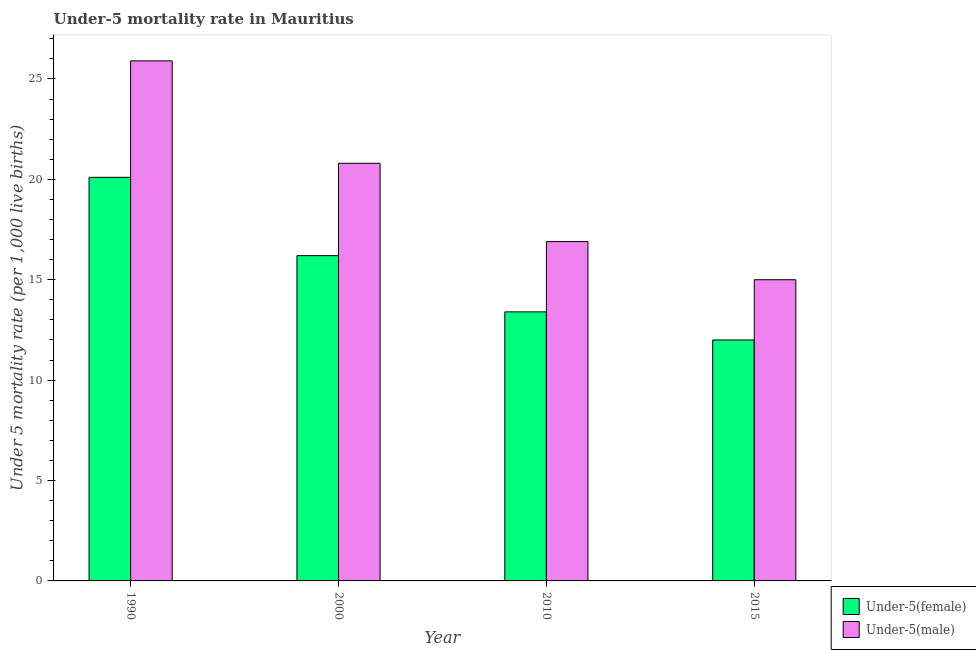How many groups of bars are there?
Keep it short and to the point. 4. Are the number of bars per tick equal to the number of legend labels?
Your response must be concise. Yes. Are the number of bars on each tick of the X-axis equal?
Keep it short and to the point. Yes. How many bars are there on the 1st tick from the left?
Offer a terse response. 2. How many bars are there on the 3rd tick from the right?
Provide a succinct answer. 2. What is the under-5 male mortality rate in 2000?
Your answer should be very brief. 20.8. Across all years, what is the maximum under-5 male mortality rate?
Ensure brevity in your answer.  25.9. Across all years, what is the minimum under-5 male mortality rate?
Provide a short and direct response. 15. In which year was the under-5 male mortality rate minimum?
Give a very brief answer. 2015. What is the total under-5 female mortality rate in the graph?
Make the answer very short. 61.7. What is the difference between the under-5 male mortality rate in 1990 and that in 2010?
Your response must be concise. 9. What is the difference between the under-5 male mortality rate in 2000 and the under-5 female mortality rate in 2010?
Your answer should be compact. 3.9. What is the average under-5 male mortality rate per year?
Give a very brief answer. 19.65. In the year 2000, what is the difference between the under-5 female mortality rate and under-5 male mortality rate?
Your response must be concise. 0. What is the ratio of the under-5 female mortality rate in 2010 to that in 2015?
Your answer should be very brief. 1.12. What is the difference between the highest and the second highest under-5 female mortality rate?
Offer a terse response. 3.9. What is the difference between the highest and the lowest under-5 female mortality rate?
Offer a very short reply. 8.1. In how many years, is the under-5 female mortality rate greater than the average under-5 female mortality rate taken over all years?
Provide a succinct answer. 2. Is the sum of the under-5 male mortality rate in 2000 and 2015 greater than the maximum under-5 female mortality rate across all years?
Offer a terse response. Yes. What does the 2nd bar from the left in 1990 represents?
Your answer should be compact. Under-5(male). What does the 2nd bar from the right in 1990 represents?
Your response must be concise. Under-5(female). How many bars are there?
Provide a short and direct response. 8. Are the values on the major ticks of Y-axis written in scientific E-notation?
Give a very brief answer. No. Does the graph contain any zero values?
Offer a very short reply. No. Does the graph contain grids?
Your answer should be very brief. No. Where does the legend appear in the graph?
Give a very brief answer. Bottom right. How are the legend labels stacked?
Your answer should be very brief. Vertical. What is the title of the graph?
Offer a very short reply. Under-5 mortality rate in Mauritius. What is the label or title of the X-axis?
Provide a succinct answer. Year. What is the label or title of the Y-axis?
Provide a succinct answer. Under 5 mortality rate (per 1,0 live births). What is the Under 5 mortality rate (per 1,000 live births) in Under-5(female) in 1990?
Give a very brief answer. 20.1. What is the Under 5 mortality rate (per 1,000 live births) in Under-5(male) in 1990?
Offer a very short reply. 25.9. What is the Under 5 mortality rate (per 1,000 live births) in Under-5(female) in 2000?
Your answer should be compact. 16.2. What is the Under 5 mortality rate (per 1,000 live births) of Under-5(male) in 2000?
Keep it short and to the point. 20.8. What is the Under 5 mortality rate (per 1,000 live births) of Under-5(male) in 2010?
Offer a very short reply. 16.9. What is the Under 5 mortality rate (per 1,000 live births) of Under-5(male) in 2015?
Your answer should be compact. 15. Across all years, what is the maximum Under 5 mortality rate (per 1,000 live births) in Under-5(female)?
Provide a succinct answer. 20.1. Across all years, what is the maximum Under 5 mortality rate (per 1,000 live births) of Under-5(male)?
Give a very brief answer. 25.9. Across all years, what is the minimum Under 5 mortality rate (per 1,000 live births) in Under-5(female)?
Keep it short and to the point. 12. Across all years, what is the minimum Under 5 mortality rate (per 1,000 live births) of Under-5(male)?
Provide a short and direct response. 15. What is the total Under 5 mortality rate (per 1,000 live births) of Under-5(female) in the graph?
Your response must be concise. 61.7. What is the total Under 5 mortality rate (per 1,000 live births) of Under-5(male) in the graph?
Provide a short and direct response. 78.6. What is the difference between the Under 5 mortality rate (per 1,000 live births) of Under-5(male) in 1990 and that in 2010?
Give a very brief answer. 9. What is the difference between the Under 5 mortality rate (per 1,000 live births) in Under-5(female) in 1990 and that in 2015?
Your answer should be very brief. 8.1. What is the difference between the Under 5 mortality rate (per 1,000 live births) of Under-5(male) in 1990 and that in 2015?
Offer a very short reply. 10.9. What is the difference between the Under 5 mortality rate (per 1,000 live births) in Under-5(male) in 2000 and that in 2010?
Offer a terse response. 3.9. What is the difference between the Under 5 mortality rate (per 1,000 live births) in Under-5(male) in 2000 and that in 2015?
Keep it short and to the point. 5.8. What is the difference between the Under 5 mortality rate (per 1,000 live births) in Under-5(male) in 2010 and that in 2015?
Give a very brief answer. 1.9. What is the difference between the Under 5 mortality rate (per 1,000 live births) of Under-5(female) in 1990 and the Under 5 mortality rate (per 1,000 live births) of Under-5(male) in 2000?
Provide a short and direct response. -0.7. What is the difference between the Under 5 mortality rate (per 1,000 live births) of Under-5(female) in 1990 and the Under 5 mortality rate (per 1,000 live births) of Under-5(male) in 2010?
Your response must be concise. 3.2. What is the difference between the Under 5 mortality rate (per 1,000 live births) in Under-5(female) in 1990 and the Under 5 mortality rate (per 1,000 live births) in Under-5(male) in 2015?
Ensure brevity in your answer.  5.1. What is the difference between the Under 5 mortality rate (per 1,000 live births) in Under-5(female) in 2010 and the Under 5 mortality rate (per 1,000 live births) in Under-5(male) in 2015?
Keep it short and to the point. -1.6. What is the average Under 5 mortality rate (per 1,000 live births) of Under-5(female) per year?
Make the answer very short. 15.43. What is the average Under 5 mortality rate (per 1,000 live births) of Under-5(male) per year?
Keep it short and to the point. 19.65. In the year 2000, what is the difference between the Under 5 mortality rate (per 1,000 live births) of Under-5(female) and Under 5 mortality rate (per 1,000 live births) of Under-5(male)?
Make the answer very short. -4.6. In the year 2015, what is the difference between the Under 5 mortality rate (per 1,000 live births) in Under-5(female) and Under 5 mortality rate (per 1,000 live births) in Under-5(male)?
Your answer should be compact. -3. What is the ratio of the Under 5 mortality rate (per 1,000 live births) in Under-5(female) in 1990 to that in 2000?
Your answer should be very brief. 1.24. What is the ratio of the Under 5 mortality rate (per 1,000 live births) of Under-5(male) in 1990 to that in 2000?
Your response must be concise. 1.25. What is the ratio of the Under 5 mortality rate (per 1,000 live births) of Under-5(male) in 1990 to that in 2010?
Offer a very short reply. 1.53. What is the ratio of the Under 5 mortality rate (per 1,000 live births) in Under-5(female) in 1990 to that in 2015?
Keep it short and to the point. 1.68. What is the ratio of the Under 5 mortality rate (per 1,000 live births) of Under-5(male) in 1990 to that in 2015?
Your answer should be very brief. 1.73. What is the ratio of the Under 5 mortality rate (per 1,000 live births) in Under-5(female) in 2000 to that in 2010?
Give a very brief answer. 1.21. What is the ratio of the Under 5 mortality rate (per 1,000 live births) in Under-5(male) in 2000 to that in 2010?
Offer a very short reply. 1.23. What is the ratio of the Under 5 mortality rate (per 1,000 live births) of Under-5(female) in 2000 to that in 2015?
Ensure brevity in your answer.  1.35. What is the ratio of the Under 5 mortality rate (per 1,000 live births) in Under-5(male) in 2000 to that in 2015?
Give a very brief answer. 1.39. What is the ratio of the Under 5 mortality rate (per 1,000 live births) of Under-5(female) in 2010 to that in 2015?
Offer a very short reply. 1.12. What is the ratio of the Under 5 mortality rate (per 1,000 live births) of Under-5(male) in 2010 to that in 2015?
Your answer should be compact. 1.13. What is the difference between the highest and the second highest Under 5 mortality rate (per 1,000 live births) of Under-5(male)?
Provide a short and direct response. 5.1. 